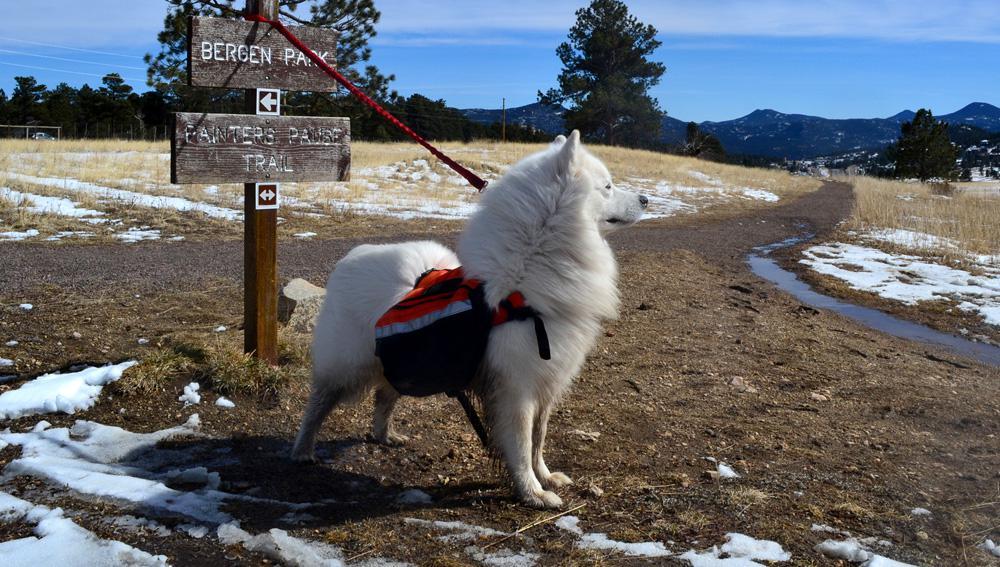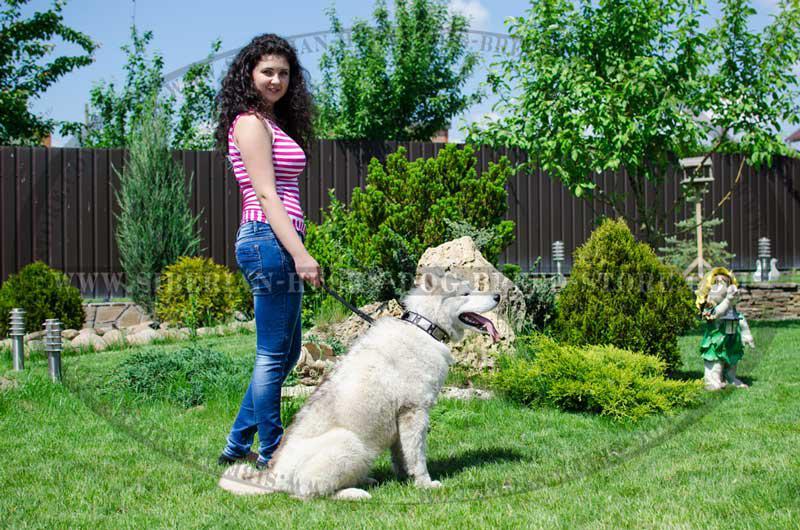The first image is the image on the left, the second image is the image on the right. Evaluate the accuracy of this statement regarding the images: "there is a dog wearing a back pack". Is it true? Answer yes or no. Yes. The first image is the image on the left, the second image is the image on the right. Given the left and right images, does the statement "A man is accompanied by a dog, and in one of the photos they are walking across a large log." hold true? Answer yes or no. No. 